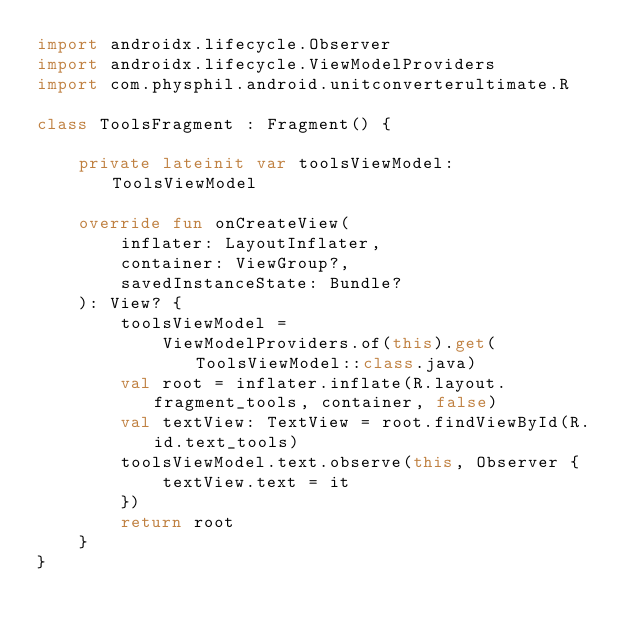<code> <loc_0><loc_0><loc_500><loc_500><_Kotlin_>import androidx.lifecycle.Observer
import androidx.lifecycle.ViewModelProviders
import com.physphil.android.unitconverterultimate.R

class ToolsFragment : Fragment() {

    private lateinit var toolsViewModel: ToolsViewModel

    override fun onCreateView(
        inflater: LayoutInflater,
        container: ViewGroup?,
        savedInstanceState: Bundle?
    ): View? {
        toolsViewModel =
            ViewModelProviders.of(this).get(ToolsViewModel::class.java)
        val root = inflater.inflate(R.layout.fragment_tools, container, false)
        val textView: TextView = root.findViewById(R.id.text_tools)
        toolsViewModel.text.observe(this, Observer {
            textView.text = it
        })
        return root
    }
}</code> 